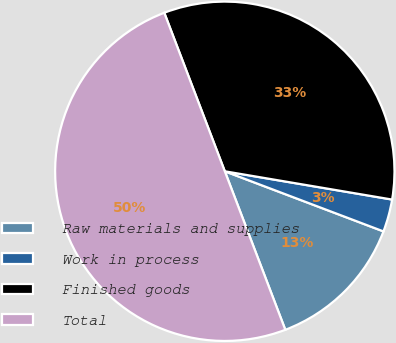Convert chart. <chart><loc_0><loc_0><loc_500><loc_500><pie_chart><fcel>Raw materials and supplies<fcel>Work in process<fcel>Finished goods<fcel>Total<nl><fcel>13.43%<fcel>3.1%<fcel>33.47%<fcel>50.0%<nl></chart> 